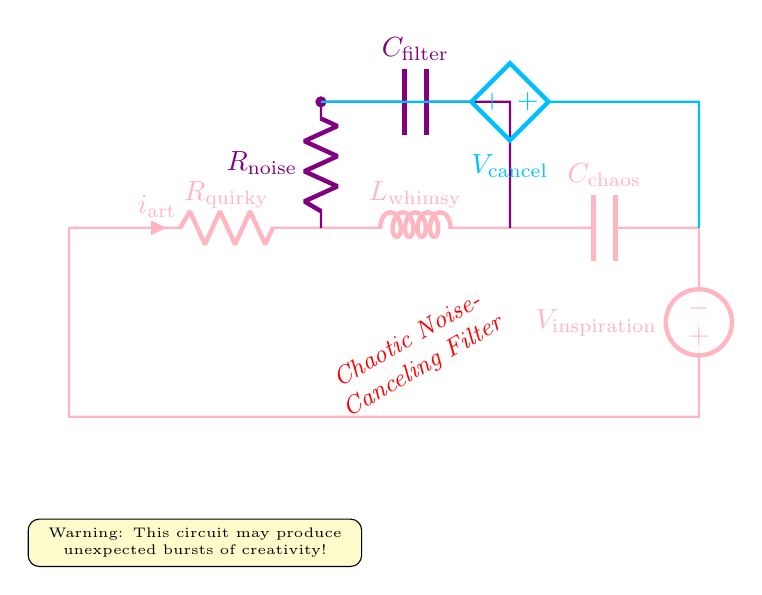What is the resistance of the quirky resistor? The quirky resistor is labeled as R\_quirky in the circuit diagram, but no specific resistance value is given. Thus, the value is not explicitly available.
Answer: Not provided What type of components makes up the chaotic noise-canceling filter? The chaotic noise-canceling filter includes a resistor, an inductor, a capacitor, and a controlled voltage source, as indicated in the circuit diagram. These are typical components found in filters.
Answer: Resistor, inductor, capacitor, controlled voltage source What is the relationship between R_noise and C_filter in this circuit? In this circuit, R_noise and C_filter are connected in parallel, which is commonly used in filters for noise cancellation. They work together to filter out unnecessary noise in the circuit.
Answer: Parallel What does the voltage source labeled V_inspiration represent? In the circuit, V_inspiration is an American voltage source. It is the input voltage that supplies power to the entire circuit, including the components that make up the noise-canceling filter.
Answer: Input voltage How does the arrangement of the chaotic noise-canceling filter affect its function? The components are arranged with R_noise and C_filter in parallel and then connected to a controlled voltage source, which implies that the circuit is designed to detect and cancel chaotic noise, allowing only desired signals to pass through, enhancing creative outputs.
Answer: Enhances creative outputs 